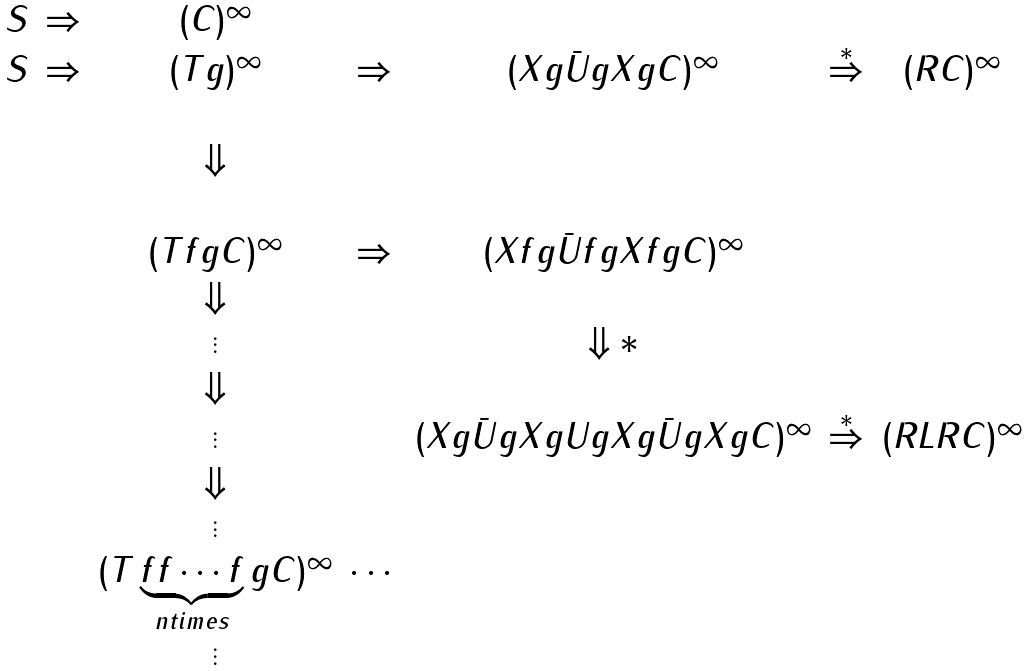Convert formula to latex. <formula><loc_0><loc_0><loc_500><loc_500>\begin{array} { c c c c c c c c c } S & \Rightarrow & ( C ) ^ { \infty } & & & & & & \\ S & \Rightarrow & ( T g ) ^ { \infty } & \Rightarrow & ( X g \bar { U } g X g C ) ^ { \infty } & \stackrel { * } { \Rightarrow } & ( R C ) ^ { \infty } & & \\ & & & & & & & & \\ & & \Downarrow & & & & & & \\ & & & & & & & & \\ & & ( T f g C ) ^ { \infty } & \Rightarrow & ( X f g \bar { U } f g X f g C ) ^ { \infty } & & & & \\ & & \Downarrow & & & & & & \\ & & \vdots & & \Downarrow * & & & & \\ & & \Downarrow & & & & & & \\ & & \vdots & & ( X g \bar { U } g X g U g X g \bar { U } g X g C ) ^ { \infty } & \stackrel { * } { \Rightarrow } & ( R L R C ) ^ { \infty } & & \\ & & \Downarrow & & & & & & \\ & & \vdots & & & & & & \\ & & ( T \underbrace { f f \cdots f } _ { n t i m e s } g C ) ^ { \infty } & \cdots & & & & & \\ & & \vdots & & & & & & \\ \end{array}</formula> 